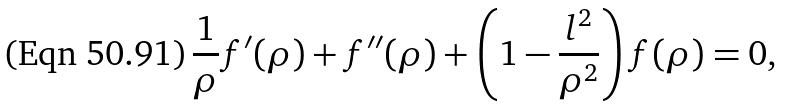Convert formula to latex. <formula><loc_0><loc_0><loc_500><loc_500>\frac { 1 } { \rho } f ^ { \prime } ( \rho ) + f ^ { \prime \prime } ( \rho ) + \left ( 1 - \frac { l ^ { 2 } } { \rho ^ { 2 } } \right ) f ( \rho ) = 0 ,</formula> 